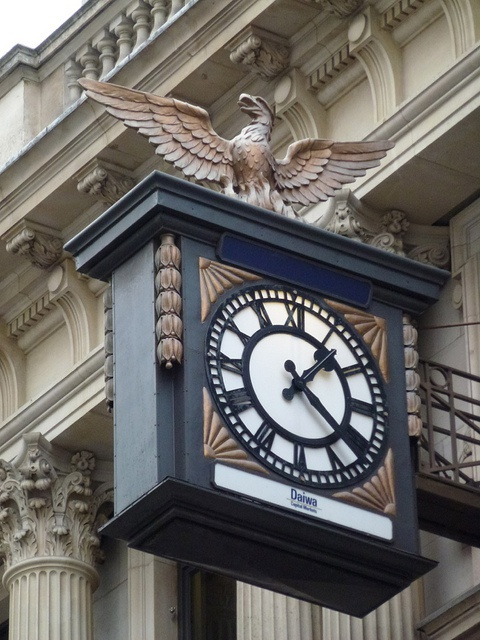Describe the objects in this image and their specific colors. I can see clock in white, black, lightgray, and gray tones and bird in white, darkgray, and gray tones in this image. 